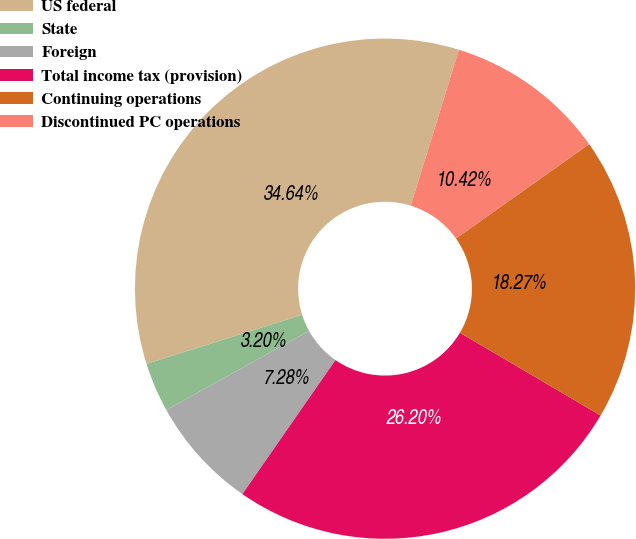Convert chart to OTSL. <chart><loc_0><loc_0><loc_500><loc_500><pie_chart><fcel>US federal<fcel>State<fcel>Foreign<fcel>Total income tax (provision)<fcel>Continuing operations<fcel>Discontinued PC operations<nl><fcel>34.64%<fcel>3.2%<fcel>7.28%<fcel>26.2%<fcel>18.27%<fcel>10.42%<nl></chart> 